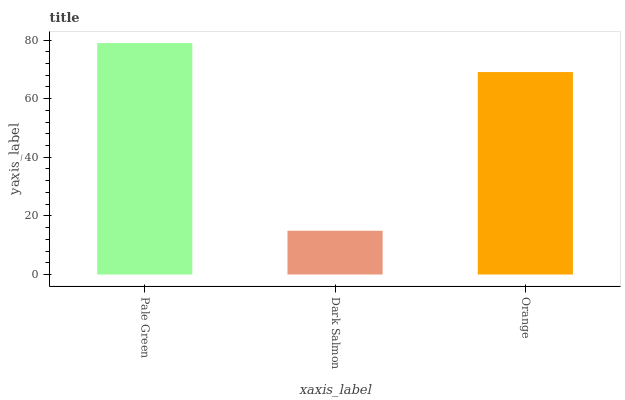Is Dark Salmon the minimum?
Answer yes or no. Yes. Is Pale Green the maximum?
Answer yes or no. Yes. Is Orange the minimum?
Answer yes or no. No. Is Orange the maximum?
Answer yes or no. No. Is Orange greater than Dark Salmon?
Answer yes or no. Yes. Is Dark Salmon less than Orange?
Answer yes or no. Yes. Is Dark Salmon greater than Orange?
Answer yes or no. No. Is Orange less than Dark Salmon?
Answer yes or no. No. Is Orange the high median?
Answer yes or no. Yes. Is Orange the low median?
Answer yes or no. Yes. Is Dark Salmon the high median?
Answer yes or no. No. Is Dark Salmon the low median?
Answer yes or no. No. 